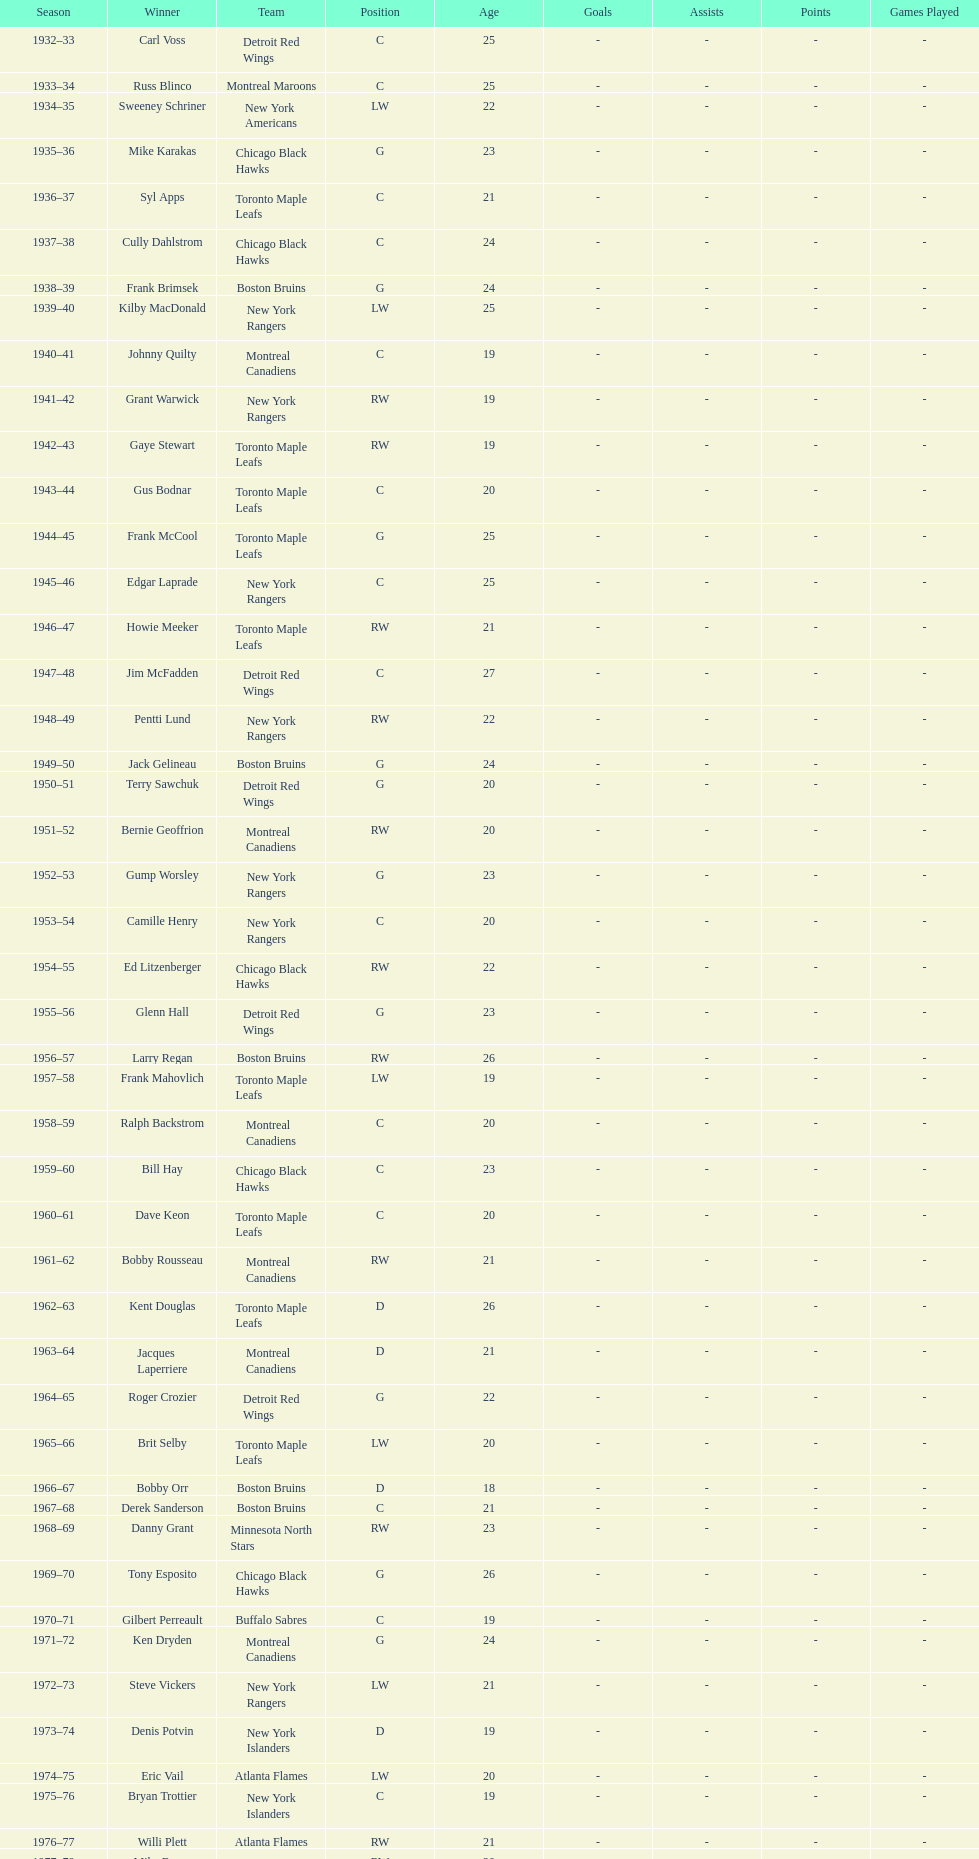How many times did the toronto maple leaves win? 9. 